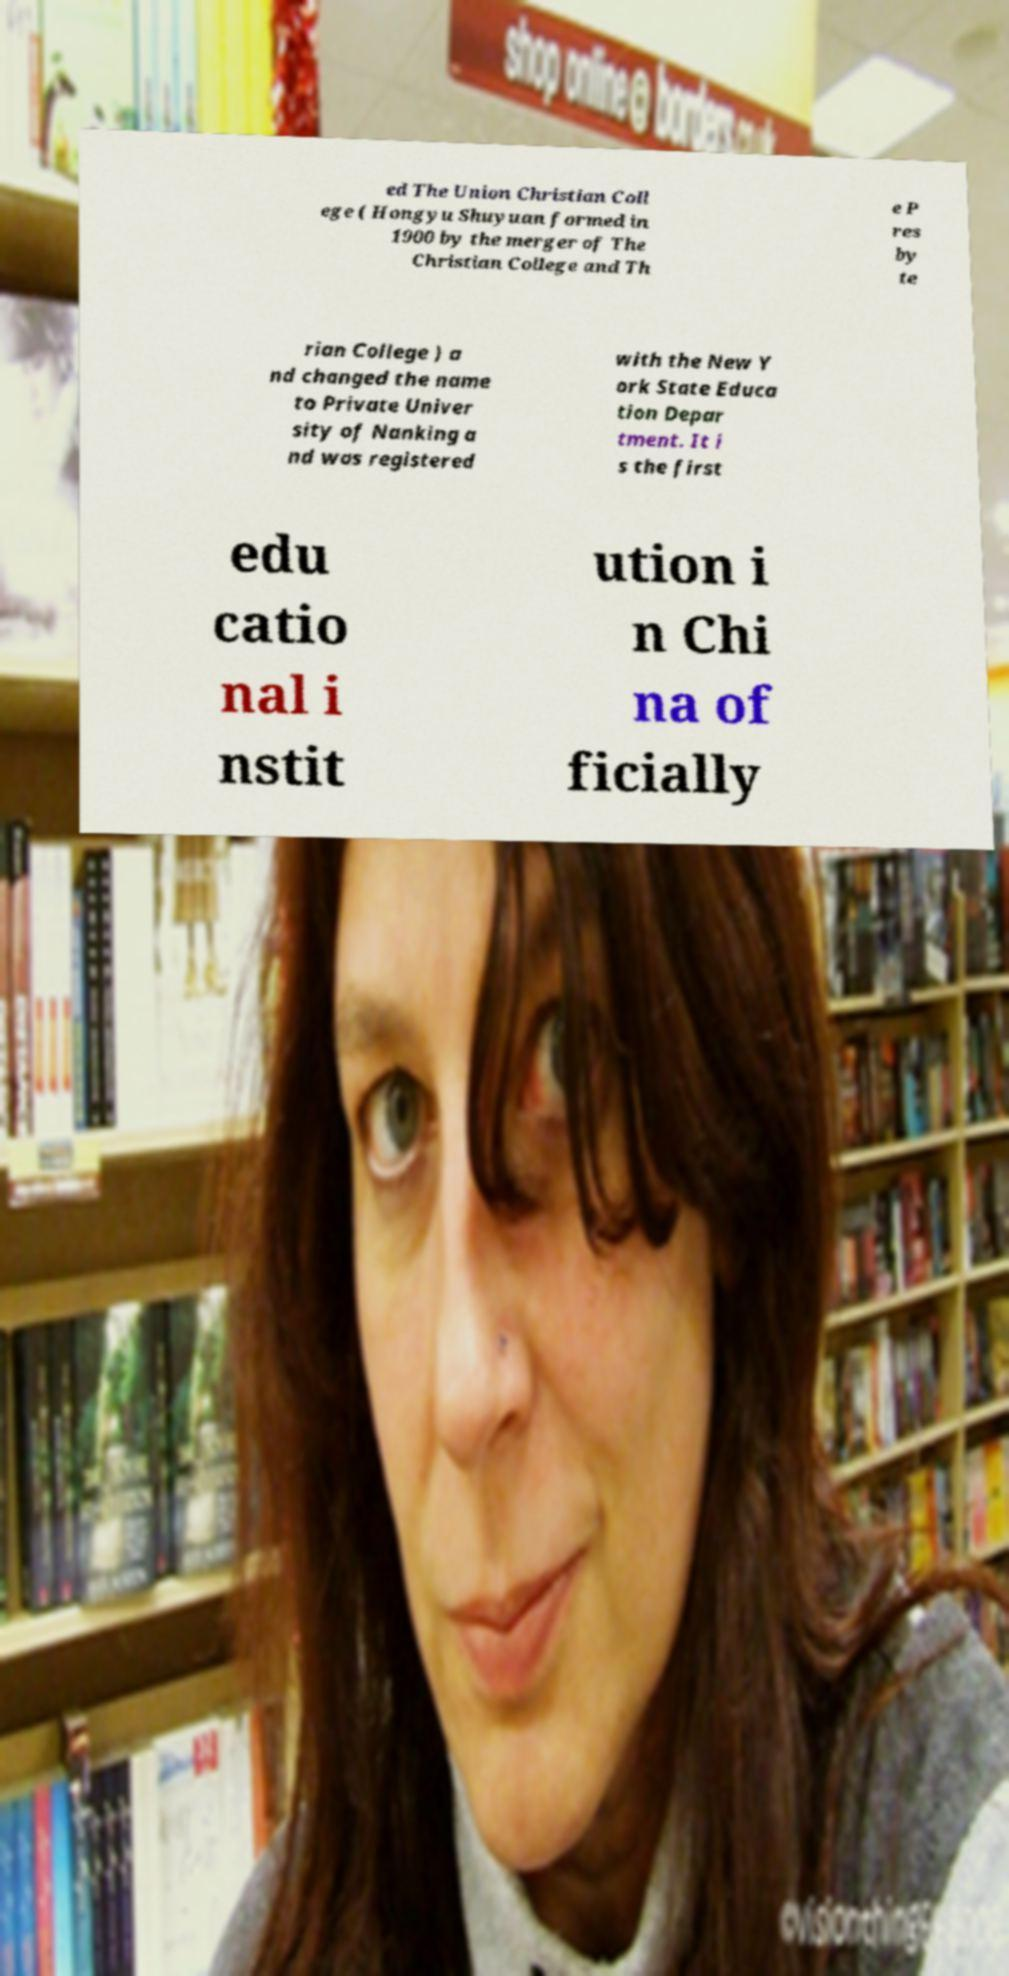Can you read and provide the text displayed in the image?This photo seems to have some interesting text. Can you extract and type it out for me? ed The Union Christian Coll ege ( Hongyu Shuyuan formed in 1900 by the merger of The Christian College and Th e P res by te rian College ) a nd changed the name to Private Univer sity of Nanking a nd was registered with the New Y ork State Educa tion Depar tment. It i s the first edu catio nal i nstit ution i n Chi na of ficially 